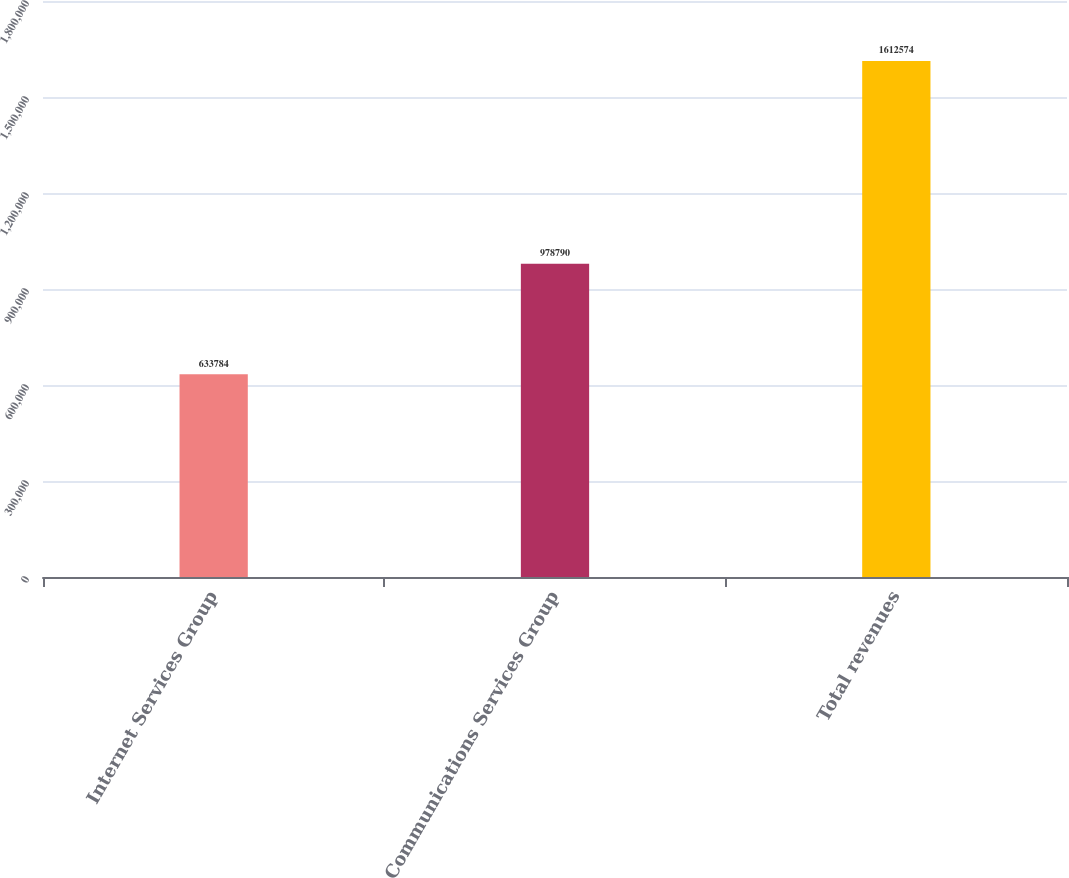<chart> <loc_0><loc_0><loc_500><loc_500><bar_chart><fcel>Internet Services Group<fcel>Communications Services Group<fcel>Total revenues<nl><fcel>633784<fcel>978790<fcel>1.61257e+06<nl></chart> 